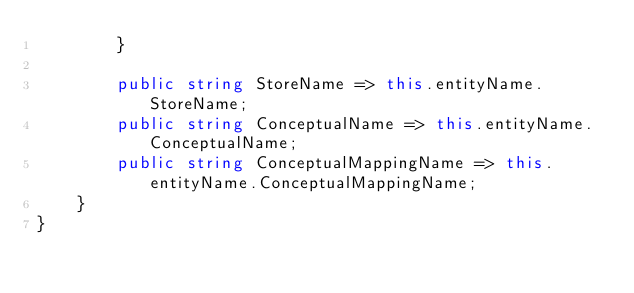Convert code to text. <code><loc_0><loc_0><loc_500><loc_500><_C#_>        }

        public string StoreName => this.entityName.StoreName;
        public string ConceptualName => this.entityName.ConceptualName;
        public string ConceptualMappingName => this.entityName.ConceptualMappingName;
    }
}
</code> 